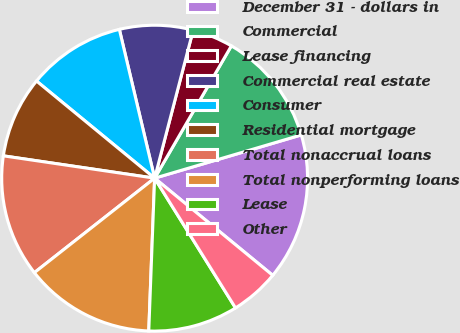<chart> <loc_0><loc_0><loc_500><loc_500><pie_chart><fcel>December 31 - dollars in<fcel>Commercial<fcel>Lease financing<fcel>Commercial real estate<fcel>Consumer<fcel>Residential mortgage<fcel>Total nonaccrual loans<fcel>Total nonperforming loans<fcel>Lease<fcel>Other<nl><fcel>15.52%<fcel>12.07%<fcel>4.31%<fcel>7.76%<fcel>10.34%<fcel>8.62%<fcel>12.93%<fcel>13.79%<fcel>9.48%<fcel>5.17%<nl></chart> 